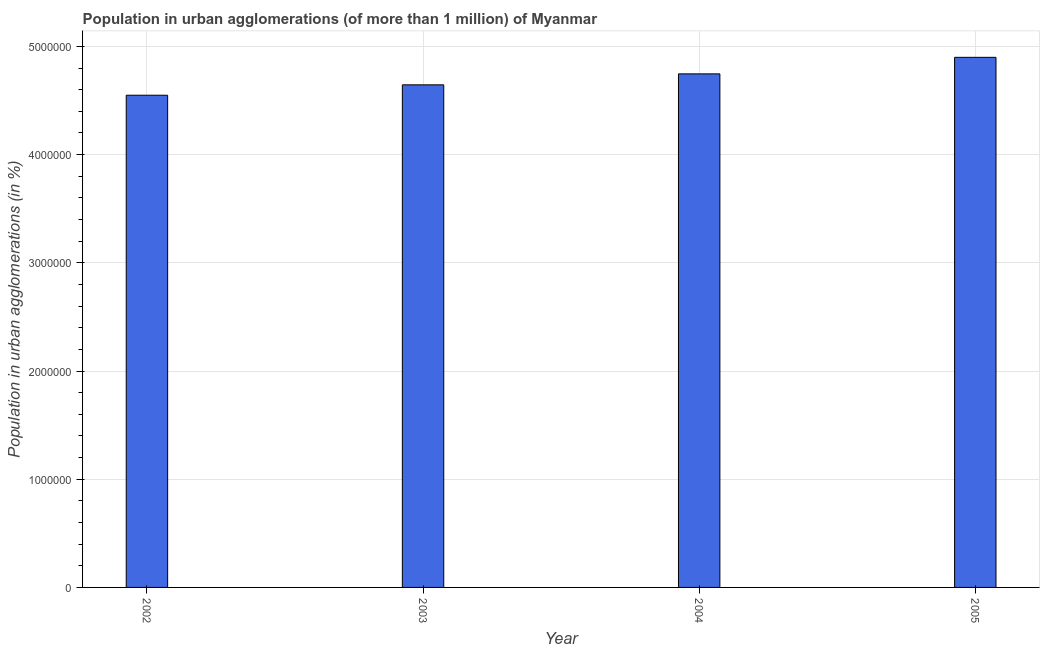What is the title of the graph?
Give a very brief answer. Population in urban agglomerations (of more than 1 million) of Myanmar. What is the label or title of the X-axis?
Make the answer very short. Year. What is the label or title of the Y-axis?
Offer a very short reply. Population in urban agglomerations (in %). What is the population in urban agglomerations in 2004?
Provide a short and direct response. 4.75e+06. Across all years, what is the maximum population in urban agglomerations?
Offer a terse response. 4.90e+06. Across all years, what is the minimum population in urban agglomerations?
Give a very brief answer. 4.55e+06. What is the sum of the population in urban agglomerations?
Offer a terse response. 1.88e+07. What is the difference between the population in urban agglomerations in 2003 and 2004?
Your answer should be compact. -1.01e+05. What is the average population in urban agglomerations per year?
Your answer should be compact. 4.71e+06. What is the median population in urban agglomerations?
Provide a short and direct response. 4.70e+06. Do a majority of the years between 2003 and 2004 (inclusive) have population in urban agglomerations greater than 1600000 %?
Give a very brief answer. Yes. Is the population in urban agglomerations in 2002 less than that in 2005?
Offer a very short reply. Yes. What is the difference between the highest and the second highest population in urban agglomerations?
Offer a terse response. 1.53e+05. What is the difference between the highest and the lowest population in urban agglomerations?
Keep it short and to the point. 3.50e+05. In how many years, is the population in urban agglomerations greater than the average population in urban agglomerations taken over all years?
Provide a short and direct response. 2. Are all the bars in the graph horizontal?
Your answer should be very brief. No. Are the values on the major ticks of Y-axis written in scientific E-notation?
Keep it short and to the point. No. What is the Population in urban agglomerations (in %) in 2002?
Give a very brief answer. 4.55e+06. What is the Population in urban agglomerations (in %) in 2003?
Your answer should be very brief. 4.64e+06. What is the Population in urban agglomerations (in %) of 2004?
Your answer should be compact. 4.75e+06. What is the Population in urban agglomerations (in %) of 2005?
Keep it short and to the point. 4.90e+06. What is the difference between the Population in urban agglomerations (in %) in 2002 and 2003?
Ensure brevity in your answer.  -9.61e+04. What is the difference between the Population in urban agglomerations (in %) in 2002 and 2004?
Provide a short and direct response. -1.97e+05. What is the difference between the Population in urban agglomerations (in %) in 2002 and 2005?
Keep it short and to the point. -3.50e+05. What is the difference between the Population in urban agglomerations (in %) in 2003 and 2004?
Provide a short and direct response. -1.01e+05. What is the difference between the Population in urban agglomerations (in %) in 2003 and 2005?
Provide a short and direct response. -2.54e+05. What is the difference between the Population in urban agglomerations (in %) in 2004 and 2005?
Your response must be concise. -1.53e+05. What is the ratio of the Population in urban agglomerations (in %) in 2002 to that in 2003?
Make the answer very short. 0.98. What is the ratio of the Population in urban agglomerations (in %) in 2002 to that in 2004?
Your answer should be compact. 0.96. What is the ratio of the Population in urban agglomerations (in %) in 2002 to that in 2005?
Ensure brevity in your answer.  0.93. What is the ratio of the Population in urban agglomerations (in %) in 2003 to that in 2004?
Give a very brief answer. 0.98. What is the ratio of the Population in urban agglomerations (in %) in 2003 to that in 2005?
Provide a succinct answer. 0.95. What is the ratio of the Population in urban agglomerations (in %) in 2004 to that in 2005?
Give a very brief answer. 0.97. 